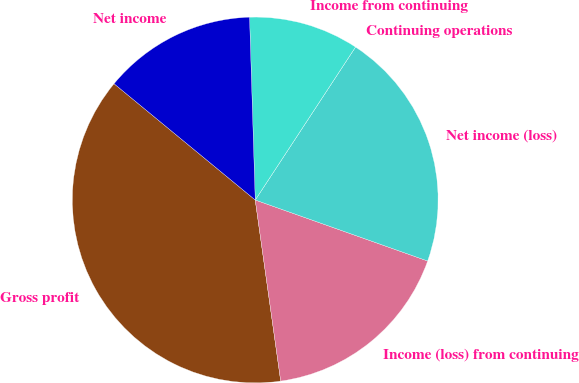<chart> <loc_0><loc_0><loc_500><loc_500><pie_chart><fcel>Gross profit<fcel>Income (loss) from continuing<fcel>Net income (loss)<fcel>Continuing operations<fcel>Income from continuing<fcel>Net income<nl><fcel>38.19%<fcel>17.36%<fcel>21.18%<fcel>0.0%<fcel>9.73%<fcel>13.54%<nl></chart> 